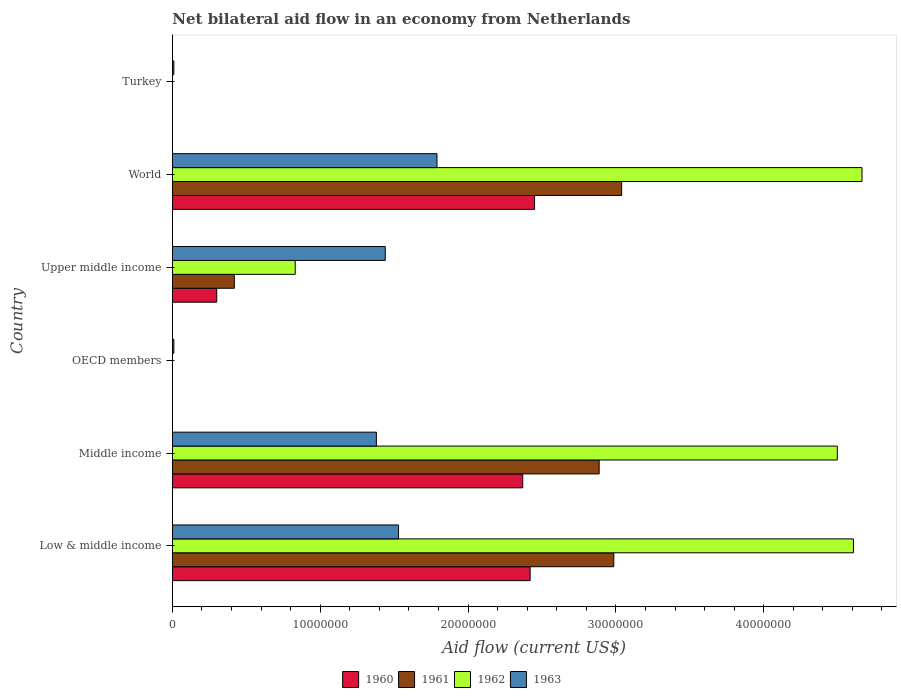How many different coloured bars are there?
Offer a terse response. 4. How many bars are there on the 6th tick from the bottom?
Ensure brevity in your answer.  1. What is the net bilateral aid flow in 1961 in Upper middle income?
Make the answer very short. 4.19e+06. Across all countries, what is the maximum net bilateral aid flow in 1962?
Provide a succinct answer. 4.66e+07. Across all countries, what is the minimum net bilateral aid flow in 1961?
Give a very brief answer. 0. What is the total net bilateral aid flow in 1963 in the graph?
Provide a short and direct response. 6.16e+07. What is the difference between the net bilateral aid flow in 1963 in Turkey and that in World?
Offer a very short reply. -1.78e+07. What is the difference between the net bilateral aid flow in 1961 in Middle income and the net bilateral aid flow in 1960 in Low & middle income?
Make the answer very short. 4.67e+06. What is the average net bilateral aid flow in 1962 per country?
Your answer should be very brief. 2.43e+07. What is the difference between the net bilateral aid flow in 1963 and net bilateral aid flow in 1961 in World?
Make the answer very short. -1.25e+07. What is the ratio of the net bilateral aid flow in 1963 in Low & middle income to that in World?
Make the answer very short. 0.85. Is the difference between the net bilateral aid flow in 1963 in Middle income and Upper middle income greater than the difference between the net bilateral aid flow in 1961 in Middle income and Upper middle income?
Your answer should be compact. No. What is the difference between the highest and the second highest net bilateral aid flow in 1961?
Your answer should be compact. 5.30e+05. What is the difference between the highest and the lowest net bilateral aid flow in 1962?
Ensure brevity in your answer.  4.66e+07. In how many countries, is the net bilateral aid flow in 1960 greater than the average net bilateral aid flow in 1960 taken over all countries?
Keep it short and to the point. 3. Is it the case that in every country, the sum of the net bilateral aid flow in 1962 and net bilateral aid flow in 1963 is greater than the net bilateral aid flow in 1961?
Make the answer very short. Yes. What is the difference between two consecutive major ticks on the X-axis?
Make the answer very short. 1.00e+07. Does the graph contain any zero values?
Your response must be concise. Yes. How many legend labels are there?
Provide a short and direct response. 4. What is the title of the graph?
Ensure brevity in your answer.  Net bilateral aid flow in an economy from Netherlands. Does "1965" appear as one of the legend labels in the graph?
Provide a succinct answer. No. What is the label or title of the X-axis?
Give a very brief answer. Aid flow (current US$). What is the Aid flow (current US$) in 1960 in Low & middle income?
Your response must be concise. 2.42e+07. What is the Aid flow (current US$) of 1961 in Low & middle income?
Your answer should be compact. 2.99e+07. What is the Aid flow (current US$) of 1962 in Low & middle income?
Provide a short and direct response. 4.61e+07. What is the Aid flow (current US$) in 1963 in Low & middle income?
Provide a succinct answer. 1.53e+07. What is the Aid flow (current US$) of 1960 in Middle income?
Your answer should be very brief. 2.37e+07. What is the Aid flow (current US$) in 1961 in Middle income?
Make the answer very short. 2.89e+07. What is the Aid flow (current US$) in 1962 in Middle income?
Give a very brief answer. 4.50e+07. What is the Aid flow (current US$) in 1963 in Middle income?
Provide a short and direct response. 1.38e+07. What is the Aid flow (current US$) of 1960 in OECD members?
Give a very brief answer. 0. What is the Aid flow (current US$) of 1963 in OECD members?
Your answer should be very brief. 1.00e+05. What is the Aid flow (current US$) in 1961 in Upper middle income?
Your response must be concise. 4.19e+06. What is the Aid flow (current US$) in 1962 in Upper middle income?
Your answer should be very brief. 8.31e+06. What is the Aid flow (current US$) in 1963 in Upper middle income?
Make the answer very short. 1.44e+07. What is the Aid flow (current US$) in 1960 in World?
Provide a succinct answer. 2.45e+07. What is the Aid flow (current US$) in 1961 in World?
Provide a short and direct response. 3.04e+07. What is the Aid flow (current US$) of 1962 in World?
Offer a terse response. 4.66e+07. What is the Aid flow (current US$) of 1963 in World?
Provide a short and direct response. 1.79e+07. Across all countries, what is the maximum Aid flow (current US$) of 1960?
Provide a succinct answer. 2.45e+07. Across all countries, what is the maximum Aid flow (current US$) of 1961?
Provide a succinct answer. 3.04e+07. Across all countries, what is the maximum Aid flow (current US$) in 1962?
Provide a succinct answer. 4.66e+07. Across all countries, what is the maximum Aid flow (current US$) in 1963?
Keep it short and to the point. 1.79e+07. Across all countries, what is the minimum Aid flow (current US$) of 1962?
Provide a succinct answer. 0. Across all countries, what is the minimum Aid flow (current US$) in 1963?
Your response must be concise. 1.00e+05. What is the total Aid flow (current US$) of 1960 in the graph?
Keep it short and to the point. 7.54e+07. What is the total Aid flow (current US$) in 1961 in the graph?
Provide a succinct answer. 9.33e+07. What is the total Aid flow (current US$) in 1962 in the graph?
Your response must be concise. 1.46e+08. What is the total Aid flow (current US$) of 1963 in the graph?
Your answer should be very brief. 6.16e+07. What is the difference between the Aid flow (current US$) of 1961 in Low & middle income and that in Middle income?
Make the answer very short. 9.90e+05. What is the difference between the Aid flow (current US$) of 1962 in Low & middle income and that in Middle income?
Your answer should be very brief. 1.09e+06. What is the difference between the Aid flow (current US$) of 1963 in Low & middle income and that in Middle income?
Provide a succinct answer. 1.50e+06. What is the difference between the Aid flow (current US$) of 1963 in Low & middle income and that in OECD members?
Keep it short and to the point. 1.52e+07. What is the difference between the Aid flow (current US$) of 1960 in Low & middle income and that in Upper middle income?
Your answer should be very brief. 2.12e+07. What is the difference between the Aid flow (current US$) in 1961 in Low & middle income and that in Upper middle income?
Provide a short and direct response. 2.57e+07. What is the difference between the Aid flow (current US$) of 1962 in Low & middle income and that in Upper middle income?
Your answer should be very brief. 3.78e+07. What is the difference between the Aid flow (current US$) of 1960 in Low & middle income and that in World?
Provide a short and direct response. -3.00e+05. What is the difference between the Aid flow (current US$) in 1961 in Low & middle income and that in World?
Your response must be concise. -5.30e+05. What is the difference between the Aid flow (current US$) of 1962 in Low & middle income and that in World?
Provide a succinct answer. -5.80e+05. What is the difference between the Aid flow (current US$) in 1963 in Low & middle income and that in World?
Offer a very short reply. -2.60e+06. What is the difference between the Aid flow (current US$) in 1963 in Low & middle income and that in Turkey?
Keep it short and to the point. 1.52e+07. What is the difference between the Aid flow (current US$) of 1963 in Middle income and that in OECD members?
Offer a very short reply. 1.37e+07. What is the difference between the Aid flow (current US$) in 1960 in Middle income and that in Upper middle income?
Your answer should be compact. 2.07e+07. What is the difference between the Aid flow (current US$) of 1961 in Middle income and that in Upper middle income?
Your response must be concise. 2.47e+07. What is the difference between the Aid flow (current US$) of 1962 in Middle income and that in Upper middle income?
Your answer should be very brief. 3.67e+07. What is the difference between the Aid flow (current US$) of 1963 in Middle income and that in Upper middle income?
Your response must be concise. -6.00e+05. What is the difference between the Aid flow (current US$) in 1960 in Middle income and that in World?
Make the answer very short. -8.00e+05. What is the difference between the Aid flow (current US$) in 1961 in Middle income and that in World?
Offer a terse response. -1.52e+06. What is the difference between the Aid flow (current US$) of 1962 in Middle income and that in World?
Your answer should be very brief. -1.67e+06. What is the difference between the Aid flow (current US$) of 1963 in Middle income and that in World?
Provide a succinct answer. -4.10e+06. What is the difference between the Aid flow (current US$) in 1963 in Middle income and that in Turkey?
Keep it short and to the point. 1.37e+07. What is the difference between the Aid flow (current US$) of 1963 in OECD members and that in Upper middle income?
Your answer should be compact. -1.43e+07. What is the difference between the Aid flow (current US$) of 1963 in OECD members and that in World?
Give a very brief answer. -1.78e+07. What is the difference between the Aid flow (current US$) of 1963 in OECD members and that in Turkey?
Your response must be concise. 0. What is the difference between the Aid flow (current US$) in 1960 in Upper middle income and that in World?
Make the answer very short. -2.15e+07. What is the difference between the Aid flow (current US$) of 1961 in Upper middle income and that in World?
Provide a short and direct response. -2.62e+07. What is the difference between the Aid flow (current US$) in 1962 in Upper middle income and that in World?
Offer a very short reply. -3.83e+07. What is the difference between the Aid flow (current US$) of 1963 in Upper middle income and that in World?
Keep it short and to the point. -3.50e+06. What is the difference between the Aid flow (current US$) in 1963 in Upper middle income and that in Turkey?
Your response must be concise. 1.43e+07. What is the difference between the Aid flow (current US$) in 1963 in World and that in Turkey?
Give a very brief answer. 1.78e+07. What is the difference between the Aid flow (current US$) in 1960 in Low & middle income and the Aid flow (current US$) in 1961 in Middle income?
Keep it short and to the point. -4.67e+06. What is the difference between the Aid flow (current US$) in 1960 in Low & middle income and the Aid flow (current US$) in 1962 in Middle income?
Give a very brief answer. -2.08e+07. What is the difference between the Aid flow (current US$) in 1960 in Low & middle income and the Aid flow (current US$) in 1963 in Middle income?
Your answer should be compact. 1.04e+07. What is the difference between the Aid flow (current US$) in 1961 in Low & middle income and the Aid flow (current US$) in 1962 in Middle income?
Your answer should be compact. -1.51e+07. What is the difference between the Aid flow (current US$) of 1961 in Low & middle income and the Aid flow (current US$) of 1963 in Middle income?
Ensure brevity in your answer.  1.61e+07. What is the difference between the Aid flow (current US$) in 1962 in Low & middle income and the Aid flow (current US$) in 1963 in Middle income?
Provide a succinct answer. 3.23e+07. What is the difference between the Aid flow (current US$) in 1960 in Low & middle income and the Aid flow (current US$) in 1963 in OECD members?
Offer a terse response. 2.41e+07. What is the difference between the Aid flow (current US$) of 1961 in Low & middle income and the Aid flow (current US$) of 1963 in OECD members?
Keep it short and to the point. 2.98e+07. What is the difference between the Aid flow (current US$) in 1962 in Low & middle income and the Aid flow (current US$) in 1963 in OECD members?
Your answer should be very brief. 4.60e+07. What is the difference between the Aid flow (current US$) of 1960 in Low & middle income and the Aid flow (current US$) of 1961 in Upper middle income?
Your answer should be very brief. 2.00e+07. What is the difference between the Aid flow (current US$) of 1960 in Low & middle income and the Aid flow (current US$) of 1962 in Upper middle income?
Ensure brevity in your answer.  1.59e+07. What is the difference between the Aid flow (current US$) of 1960 in Low & middle income and the Aid flow (current US$) of 1963 in Upper middle income?
Give a very brief answer. 9.80e+06. What is the difference between the Aid flow (current US$) in 1961 in Low & middle income and the Aid flow (current US$) in 1962 in Upper middle income?
Provide a succinct answer. 2.16e+07. What is the difference between the Aid flow (current US$) of 1961 in Low & middle income and the Aid flow (current US$) of 1963 in Upper middle income?
Your response must be concise. 1.55e+07. What is the difference between the Aid flow (current US$) of 1962 in Low & middle income and the Aid flow (current US$) of 1963 in Upper middle income?
Make the answer very short. 3.17e+07. What is the difference between the Aid flow (current US$) of 1960 in Low & middle income and the Aid flow (current US$) of 1961 in World?
Offer a terse response. -6.19e+06. What is the difference between the Aid flow (current US$) of 1960 in Low & middle income and the Aid flow (current US$) of 1962 in World?
Provide a short and direct response. -2.24e+07. What is the difference between the Aid flow (current US$) of 1960 in Low & middle income and the Aid flow (current US$) of 1963 in World?
Your answer should be compact. 6.30e+06. What is the difference between the Aid flow (current US$) of 1961 in Low & middle income and the Aid flow (current US$) of 1962 in World?
Keep it short and to the point. -1.68e+07. What is the difference between the Aid flow (current US$) of 1961 in Low & middle income and the Aid flow (current US$) of 1963 in World?
Offer a very short reply. 1.20e+07. What is the difference between the Aid flow (current US$) in 1962 in Low & middle income and the Aid flow (current US$) in 1963 in World?
Offer a very short reply. 2.82e+07. What is the difference between the Aid flow (current US$) in 1960 in Low & middle income and the Aid flow (current US$) in 1963 in Turkey?
Offer a terse response. 2.41e+07. What is the difference between the Aid flow (current US$) of 1961 in Low & middle income and the Aid flow (current US$) of 1963 in Turkey?
Provide a succinct answer. 2.98e+07. What is the difference between the Aid flow (current US$) in 1962 in Low & middle income and the Aid flow (current US$) in 1963 in Turkey?
Your answer should be very brief. 4.60e+07. What is the difference between the Aid flow (current US$) in 1960 in Middle income and the Aid flow (current US$) in 1963 in OECD members?
Provide a short and direct response. 2.36e+07. What is the difference between the Aid flow (current US$) in 1961 in Middle income and the Aid flow (current US$) in 1963 in OECD members?
Keep it short and to the point. 2.88e+07. What is the difference between the Aid flow (current US$) in 1962 in Middle income and the Aid flow (current US$) in 1963 in OECD members?
Make the answer very short. 4.49e+07. What is the difference between the Aid flow (current US$) in 1960 in Middle income and the Aid flow (current US$) in 1961 in Upper middle income?
Keep it short and to the point. 1.95e+07. What is the difference between the Aid flow (current US$) of 1960 in Middle income and the Aid flow (current US$) of 1962 in Upper middle income?
Keep it short and to the point. 1.54e+07. What is the difference between the Aid flow (current US$) of 1960 in Middle income and the Aid flow (current US$) of 1963 in Upper middle income?
Ensure brevity in your answer.  9.30e+06. What is the difference between the Aid flow (current US$) in 1961 in Middle income and the Aid flow (current US$) in 1962 in Upper middle income?
Your answer should be very brief. 2.06e+07. What is the difference between the Aid flow (current US$) in 1961 in Middle income and the Aid flow (current US$) in 1963 in Upper middle income?
Your answer should be very brief. 1.45e+07. What is the difference between the Aid flow (current US$) in 1962 in Middle income and the Aid flow (current US$) in 1963 in Upper middle income?
Offer a terse response. 3.06e+07. What is the difference between the Aid flow (current US$) of 1960 in Middle income and the Aid flow (current US$) of 1961 in World?
Offer a very short reply. -6.69e+06. What is the difference between the Aid flow (current US$) of 1960 in Middle income and the Aid flow (current US$) of 1962 in World?
Give a very brief answer. -2.30e+07. What is the difference between the Aid flow (current US$) of 1960 in Middle income and the Aid flow (current US$) of 1963 in World?
Provide a short and direct response. 5.80e+06. What is the difference between the Aid flow (current US$) in 1961 in Middle income and the Aid flow (current US$) in 1962 in World?
Provide a succinct answer. -1.78e+07. What is the difference between the Aid flow (current US$) of 1961 in Middle income and the Aid flow (current US$) of 1963 in World?
Provide a short and direct response. 1.10e+07. What is the difference between the Aid flow (current US$) of 1962 in Middle income and the Aid flow (current US$) of 1963 in World?
Keep it short and to the point. 2.71e+07. What is the difference between the Aid flow (current US$) of 1960 in Middle income and the Aid flow (current US$) of 1963 in Turkey?
Give a very brief answer. 2.36e+07. What is the difference between the Aid flow (current US$) of 1961 in Middle income and the Aid flow (current US$) of 1963 in Turkey?
Your response must be concise. 2.88e+07. What is the difference between the Aid flow (current US$) of 1962 in Middle income and the Aid flow (current US$) of 1963 in Turkey?
Offer a very short reply. 4.49e+07. What is the difference between the Aid flow (current US$) in 1960 in Upper middle income and the Aid flow (current US$) in 1961 in World?
Give a very brief answer. -2.74e+07. What is the difference between the Aid flow (current US$) in 1960 in Upper middle income and the Aid flow (current US$) in 1962 in World?
Give a very brief answer. -4.36e+07. What is the difference between the Aid flow (current US$) in 1960 in Upper middle income and the Aid flow (current US$) in 1963 in World?
Offer a very short reply. -1.49e+07. What is the difference between the Aid flow (current US$) of 1961 in Upper middle income and the Aid flow (current US$) of 1962 in World?
Provide a succinct answer. -4.25e+07. What is the difference between the Aid flow (current US$) in 1961 in Upper middle income and the Aid flow (current US$) in 1963 in World?
Give a very brief answer. -1.37e+07. What is the difference between the Aid flow (current US$) in 1962 in Upper middle income and the Aid flow (current US$) in 1963 in World?
Ensure brevity in your answer.  -9.59e+06. What is the difference between the Aid flow (current US$) in 1960 in Upper middle income and the Aid flow (current US$) in 1963 in Turkey?
Your answer should be very brief. 2.90e+06. What is the difference between the Aid flow (current US$) in 1961 in Upper middle income and the Aid flow (current US$) in 1963 in Turkey?
Provide a succinct answer. 4.09e+06. What is the difference between the Aid flow (current US$) of 1962 in Upper middle income and the Aid flow (current US$) of 1963 in Turkey?
Your answer should be very brief. 8.21e+06. What is the difference between the Aid flow (current US$) in 1960 in World and the Aid flow (current US$) in 1963 in Turkey?
Give a very brief answer. 2.44e+07. What is the difference between the Aid flow (current US$) of 1961 in World and the Aid flow (current US$) of 1963 in Turkey?
Provide a succinct answer. 3.03e+07. What is the difference between the Aid flow (current US$) of 1962 in World and the Aid flow (current US$) of 1963 in Turkey?
Offer a terse response. 4.66e+07. What is the average Aid flow (current US$) of 1960 per country?
Your answer should be very brief. 1.26e+07. What is the average Aid flow (current US$) of 1961 per country?
Your response must be concise. 1.56e+07. What is the average Aid flow (current US$) of 1962 per country?
Offer a terse response. 2.43e+07. What is the average Aid flow (current US$) in 1963 per country?
Offer a terse response. 1.03e+07. What is the difference between the Aid flow (current US$) of 1960 and Aid flow (current US$) of 1961 in Low & middle income?
Your response must be concise. -5.66e+06. What is the difference between the Aid flow (current US$) of 1960 and Aid flow (current US$) of 1962 in Low & middle income?
Offer a very short reply. -2.19e+07. What is the difference between the Aid flow (current US$) in 1960 and Aid flow (current US$) in 1963 in Low & middle income?
Offer a very short reply. 8.90e+06. What is the difference between the Aid flow (current US$) of 1961 and Aid flow (current US$) of 1962 in Low & middle income?
Keep it short and to the point. -1.62e+07. What is the difference between the Aid flow (current US$) in 1961 and Aid flow (current US$) in 1963 in Low & middle income?
Your answer should be compact. 1.46e+07. What is the difference between the Aid flow (current US$) of 1962 and Aid flow (current US$) of 1963 in Low & middle income?
Ensure brevity in your answer.  3.08e+07. What is the difference between the Aid flow (current US$) in 1960 and Aid flow (current US$) in 1961 in Middle income?
Your answer should be compact. -5.17e+06. What is the difference between the Aid flow (current US$) of 1960 and Aid flow (current US$) of 1962 in Middle income?
Ensure brevity in your answer.  -2.13e+07. What is the difference between the Aid flow (current US$) of 1960 and Aid flow (current US$) of 1963 in Middle income?
Provide a short and direct response. 9.90e+06. What is the difference between the Aid flow (current US$) of 1961 and Aid flow (current US$) of 1962 in Middle income?
Ensure brevity in your answer.  -1.61e+07. What is the difference between the Aid flow (current US$) in 1961 and Aid flow (current US$) in 1963 in Middle income?
Your answer should be very brief. 1.51e+07. What is the difference between the Aid flow (current US$) in 1962 and Aid flow (current US$) in 1963 in Middle income?
Offer a very short reply. 3.12e+07. What is the difference between the Aid flow (current US$) of 1960 and Aid flow (current US$) of 1961 in Upper middle income?
Ensure brevity in your answer.  -1.19e+06. What is the difference between the Aid flow (current US$) of 1960 and Aid flow (current US$) of 1962 in Upper middle income?
Your response must be concise. -5.31e+06. What is the difference between the Aid flow (current US$) of 1960 and Aid flow (current US$) of 1963 in Upper middle income?
Ensure brevity in your answer.  -1.14e+07. What is the difference between the Aid flow (current US$) in 1961 and Aid flow (current US$) in 1962 in Upper middle income?
Ensure brevity in your answer.  -4.12e+06. What is the difference between the Aid flow (current US$) of 1961 and Aid flow (current US$) of 1963 in Upper middle income?
Give a very brief answer. -1.02e+07. What is the difference between the Aid flow (current US$) in 1962 and Aid flow (current US$) in 1963 in Upper middle income?
Provide a succinct answer. -6.09e+06. What is the difference between the Aid flow (current US$) of 1960 and Aid flow (current US$) of 1961 in World?
Your response must be concise. -5.89e+06. What is the difference between the Aid flow (current US$) of 1960 and Aid flow (current US$) of 1962 in World?
Ensure brevity in your answer.  -2.22e+07. What is the difference between the Aid flow (current US$) in 1960 and Aid flow (current US$) in 1963 in World?
Ensure brevity in your answer.  6.60e+06. What is the difference between the Aid flow (current US$) of 1961 and Aid flow (current US$) of 1962 in World?
Make the answer very short. -1.63e+07. What is the difference between the Aid flow (current US$) in 1961 and Aid flow (current US$) in 1963 in World?
Ensure brevity in your answer.  1.25e+07. What is the difference between the Aid flow (current US$) of 1962 and Aid flow (current US$) of 1963 in World?
Offer a very short reply. 2.88e+07. What is the ratio of the Aid flow (current US$) of 1960 in Low & middle income to that in Middle income?
Ensure brevity in your answer.  1.02. What is the ratio of the Aid flow (current US$) of 1961 in Low & middle income to that in Middle income?
Offer a very short reply. 1.03. What is the ratio of the Aid flow (current US$) in 1962 in Low & middle income to that in Middle income?
Keep it short and to the point. 1.02. What is the ratio of the Aid flow (current US$) in 1963 in Low & middle income to that in Middle income?
Make the answer very short. 1.11. What is the ratio of the Aid flow (current US$) of 1963 in Low & middle income to that in OECD members?
Keep it short and to the point. 153. What is the ratio of the Aid flow (current US$) of 1960 in Low & middle income to that in Upper middle income?
Ensure brevity in your answer.  8.07. What is the ratio of the Aid flow (current US$) in 1961 in Low & middle income to that in Upper middle income?
Ensure brevity in your answer.  7.13. What is the ratio of the Aid flow (current US$) in 1962 in Low & middle income to that in Upper middle income?
Your answer should be very brief. 5.54. What is the ratio of the Aid flow (current US$) of 1963 in Low & middle income to that in Upper middle income?
Keep it short and to the point. 1.06. What is the ratio of the Aid flow (current US$) in 1961 in Low & middle income to that in World?
Provide a short and direct response. 0.98. What is the ratio of the Aid flow (current US$) of 1962 in Low & middle income to that in World?
Keep it short and to the point. 0.99. What is the ratio of the Aid flow (current US$) in 1963 in Low & middle income to that in World?
Keep it short and to the point. 0.85. What is the ratio of the Aid flow (current US$) in 1963 in Low & middle income to that in Turkey?
Make the answer very short. 153. What is the ratio of the Aid flow (current US$) in 1963 in Middle income to that in OECD members?
Keep it short and to the point. 138. What is the ratio of the Aid flow (current US$) of 1960 in Middle income to that in Upper middle income?
Offer a very short reply. 7.9. What is the ratio of the Aid flow (current US$) in 1961 in Middle income to that in Upper middle income?
Ensure brevity in your answer.  6.89. What is the ratio of the Aid flow (current US$) in 1962 in Middle income to that in Upper middle income?
Make the answer very short. 5.41. What is the ratio of the Aid flow (current US$) of 1963 in Middle income to that in Upper middle income?
Ensure brevity in your answer.  0.96. What is the ratio of the Aid flow (current US$) of 1960 in Middle income to that in World?
Make the answer very short. 0.97. What is the ratio of the Aid flow (current US$) in 1962 in Middle income to that in World?
Provide a succinct answer. 0.96. What is the ratio of the Aid flow (current US$) in 1963 in Middle income to that in World?
Ensure brevity in your answer.  0.77. What is the ratio of the Aid flow (current US$) in 1963 in Middle income to that in Turkey?
Your answer should be very brief. 138. What is the ratio of the Aid flow (current US$) of 1963 in OECD members to that in Upper middle income?
Your response must be concise. 0.01. What is the ratio of the Aid flow (current US$) in 1963 in OECD members to that in World?
Provide a short and direct response. 0.01. What is the ratio of the Aid flow (current US$) in 1960 in Upper middle income to that in World?
Keep it short and to the point. 0.12. What is the ratio of the Aid flow (current US$) of 1961 in Upper middle income to that in World?
Your response must be concise. 0.14. What is the ratio of the Aid flow (current US$) of 1962 in Upper middle income to that in World?
Make the answer very short. 0.18. What is the ratio of the Aid flow (current US$) in 1963 in Upper middle income to that in World?
Offer a very short reply. 0.8. What is the ratio of the Aid flow (current US$) in 1963 in Upper middle income to that in Turkey?
Your response must be concise. 144. What is the ratio of the Aid flow (current US$) of 1963 in World to that in Turkey?
Provide a succinct answer. 179. What is the difference between the highest and the second highest Aid flow (current US$) of 1960?
Your answer should be compact. 3.00e+05. What is the difference between the highest and the second highest Aid flow (current US$) in 1961?
Offer a very short reply. 5.30e+05. What is the difference between the highest and the second highest Aid flow (current US$) in 1962?
Offer a very short reply. 5.80e+05. What is the difference between the highest and the second highest Aid flow (current US$) of 1963?
Provide a succinct answer. 2.60e+06. What is the difference between the highest and the lowest Aid flow (current US$) of 1960?
Your response must be concise. 2.45e+07. What is the difference between the highest and the lowest Aid flow (current US$) of 1961?
Provide a succinct answer. 3.04e+07. What is the difference between the highest and the lowest Aid flow (current US$) of 1962?
Provide a short and direct response. 4.66e+07. What is the difference between the highest and the lowest Aid flow (current US$) in 1963?
Provide a succinct answer. 1.78e+07. 